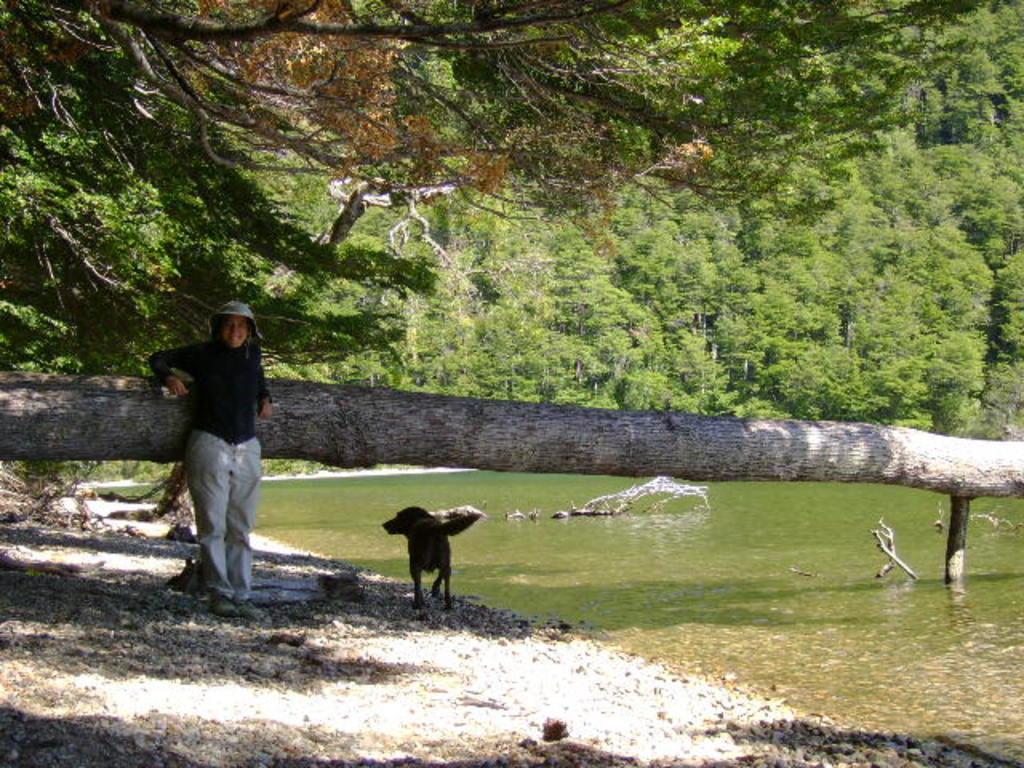In one or two sentences, can you explain what this image depicts? In the foreground of the picture there are stones, water, trunk of a tree, woman and dog. In the center of the picture there are trees and water. It is sunny 